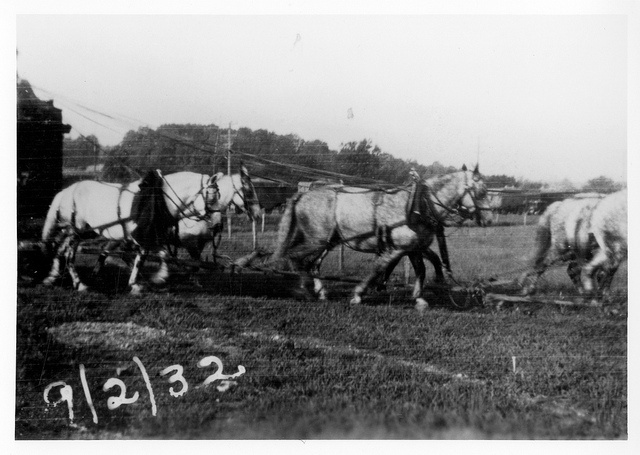Describe the objects in this image and their specific colors. I can see horse in white, black, darkgray, gray, and lightgray tones, horse in white, darkgray, gray, lightgray, and black tones, horse in white, black, darkgray, gray, and lightgray tones, and horse in white, lightgray, darkgray, gray, and black tones in this image. 